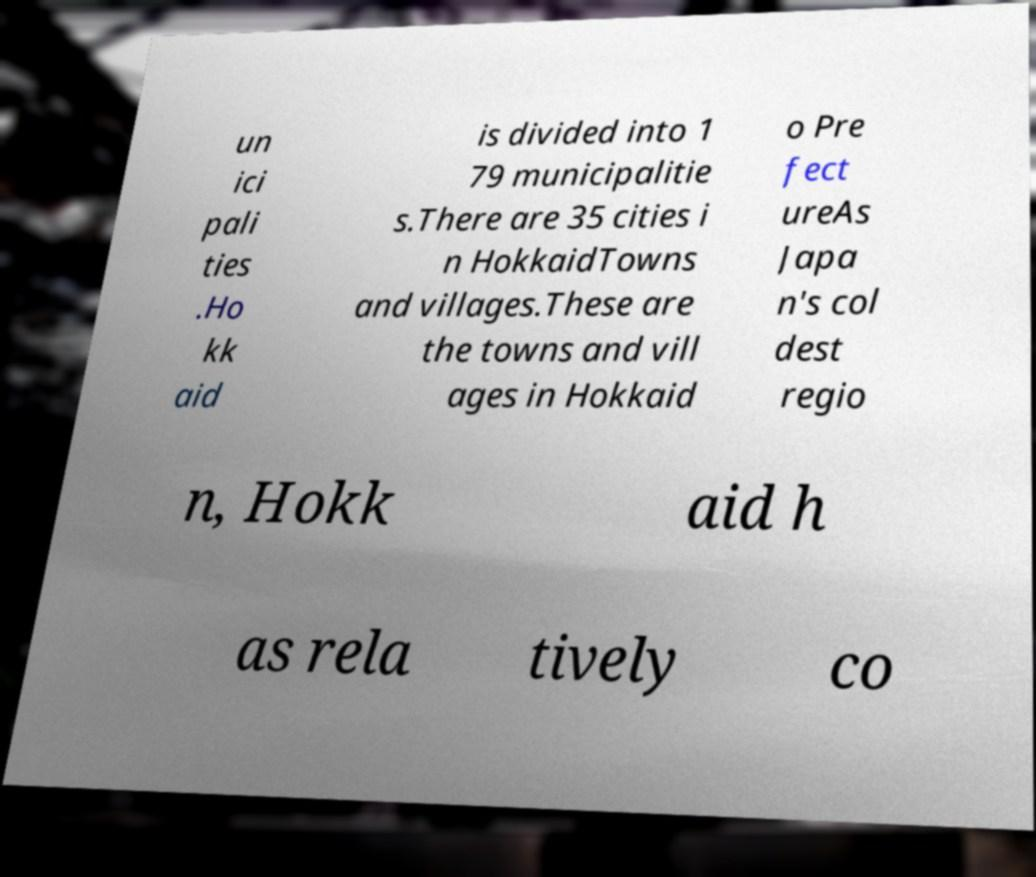There's text embedded in this image that I need extracted. Can you transcribe it verbatim? un ici pali ties .Ho kk aid is divided into 1 79 municipalitie s.There are 35 cities i n HokkaidTowns and villages.These are the towns and vill ages in Hokkaid o Pre fect ureAs Japa n's col dest regio n, Hokk aid h as rela tively co 